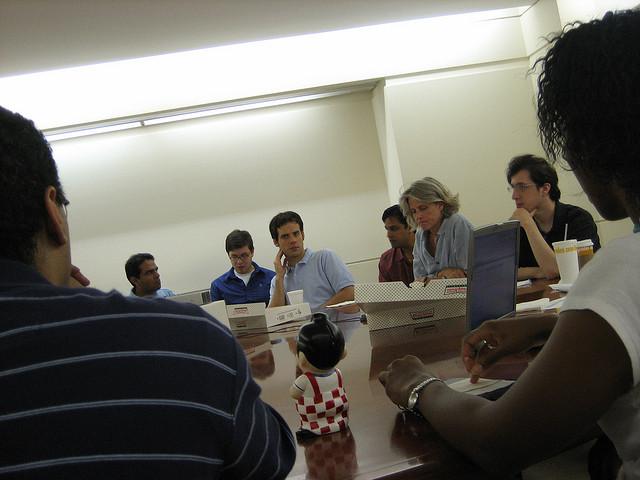How many people are wearing hats?
Quick response, please. 0. Is it a meeting?
Answer briefly. Yes. What figurine is sitting on the table?
Short answer required. Big boy. 